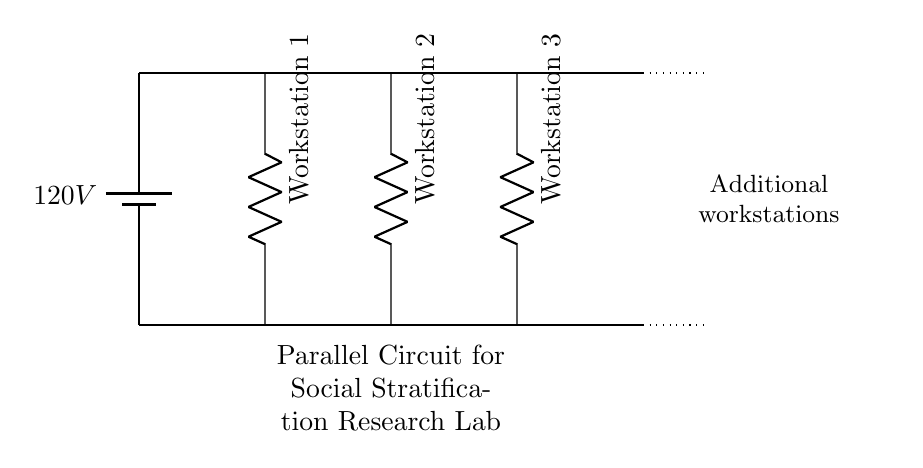What is the voltage of the power source? The circuit shows a battery labeled with a voltage of 120 volts. Therefore, the voltage of the power source is directly read from this label.
Answer: 120 volts How many workstations are connected in parallel? The diagram displays three resistors, each labeled as a workstation, indicating that there are three workstations connected in parallel to the power source.
Answer: Three What is the role of the dotted lines in the diagram? The dotted lines are used to signify potential future expansion of the circuit, suggesting that additional workstations can be added later on.
Answer: Future expansion If one workstation fails, what happens to the others? In a parallel circuit, if one component (workstation) fails, it does not affect the operation of the other workstations; they continue to function independently.
Answer: They remain functional What kind of circuit is represented in this diagram? The circuit is characterized by multiple components (workstations) connected across common voltage points (the same two nodes), which is a defining feature of parallel circuits.
Answer: Parallel circuit What type of components are the workstations? The workstations are represented by resistors in the diagram, which indicates they have a defined resistance and are part of the circuit's load.
Answer: Resistors What is the total voltage across all workstations? In a parallel configuration, the voltage across each component is the same as the total voltage supplied by the power source, which is 120 volts in this case.
Answer: 120 volts 